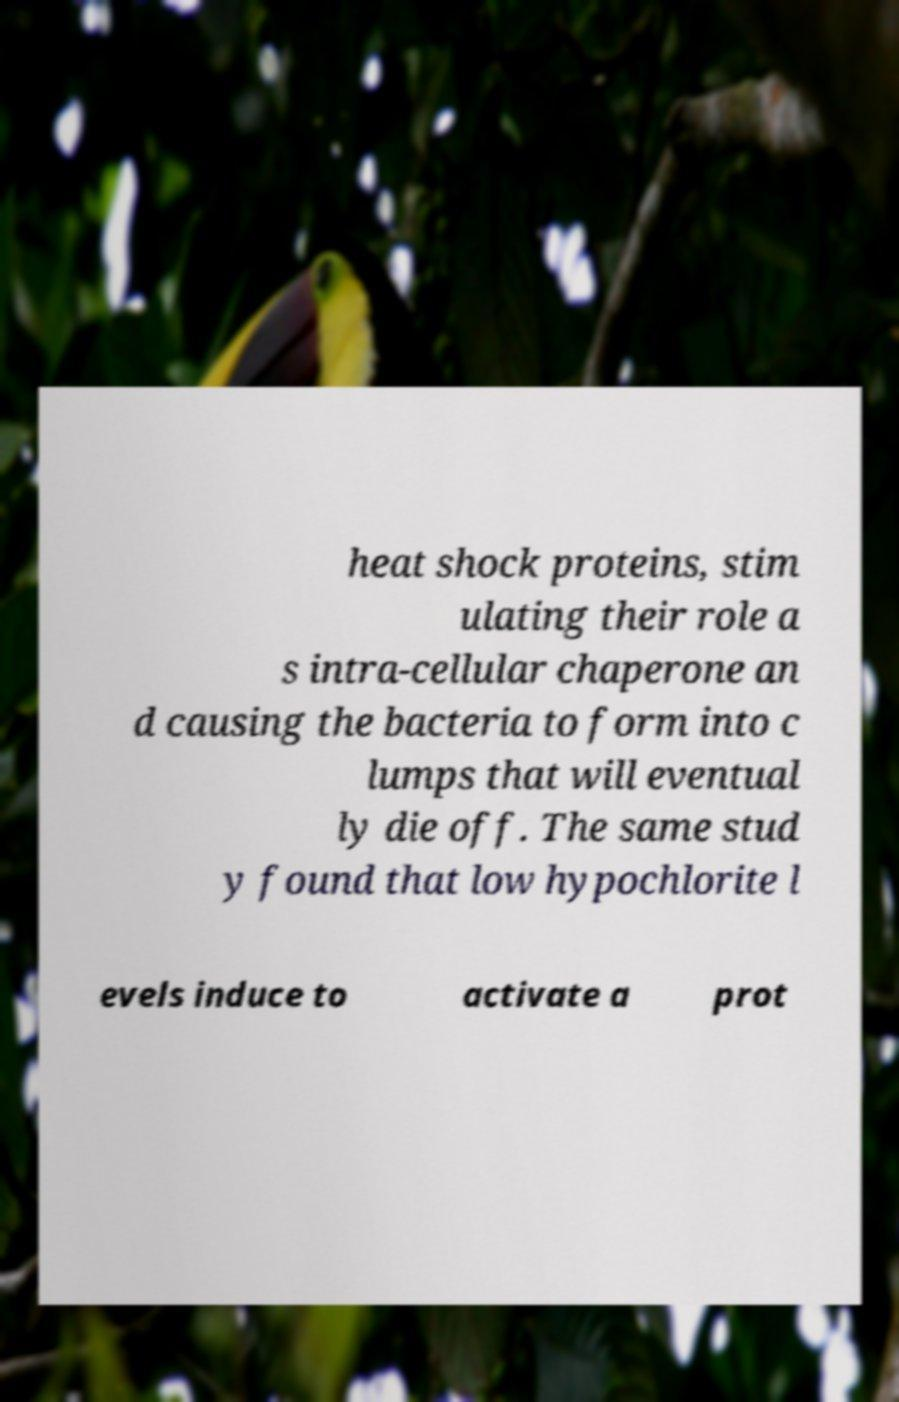Could you extract and type out the text from this image? heat shock proteins, stim ulating their role a s intra-cellular chaperone an d causing the bacteria to form into c lumps that will eventual ly die off. The same stud y found that low hypochlorite l evels induce to activate a prot 